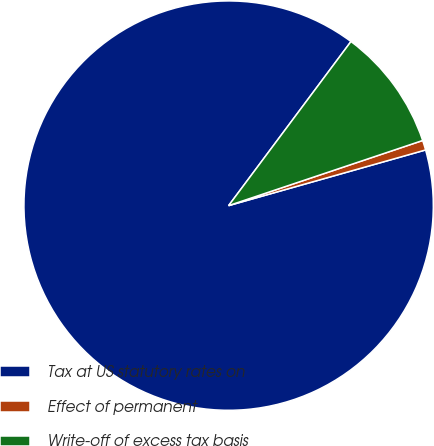Convert chart. <chart><loc_0><loc_0><loc_500><loc_500><pie_chart><fcel>Tax at US statutory rates on<fcel>Effect of permanent<fcel>Write-off of excess tax basis<nl><fcel>89.58%<fcel>0.77%<fcel>9.65%<nl></chart> 